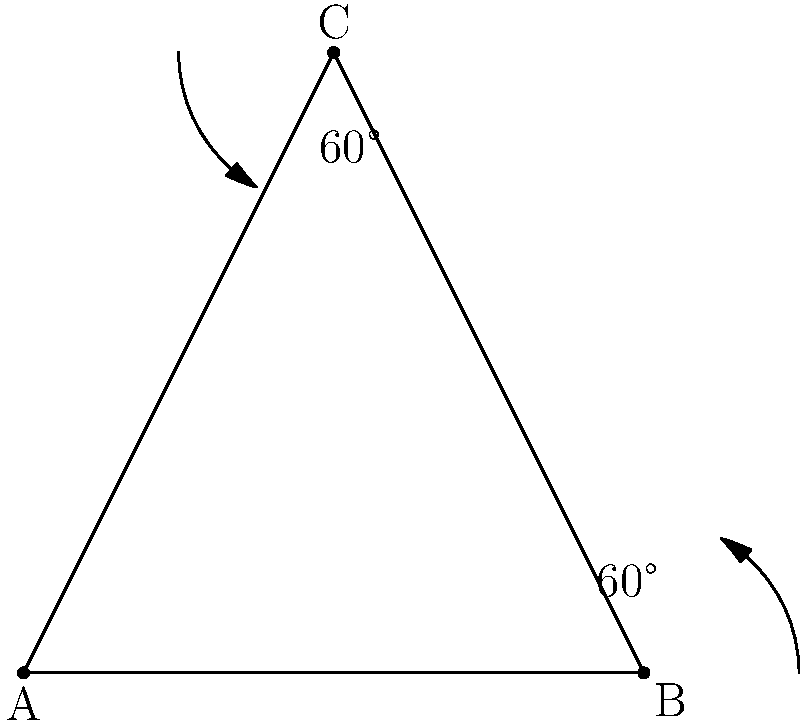In the spirit of understanding different prayer positions, consider a triangle formed by the hands and body during prayer. If the angle between the hands is 60°, and the angle between one hand and the body is also 60°, what is the measure of the third angle in this prayer triangle? Let's approach this step-by-step:

1) First, recall that the sum of angles in any triangle is always 180°. This is a fundamental property of triangles.

2) In our prayer triangle, we're given two angles:
   - The angle between the hands: 60°
   - The angle between one hand and the body: 60°

3) Let's call the third angle (the one we're looking for) $x$.

4) We can set up an equation based on the fact that all angles must sum to 180°:
   
   $60° + 60° + x = 180°$

5) Simplify the left side of the equation:
   
   $120° + x = 180°$

6) To solve for $x$, subtract 120° from both sides:
   
   $x = 180° - 120° = 60°$

Therefore, the measure of the third angle in this prayer triangle is also 60°.

This creates a special type of triangle known as an equilateral triangle, where all sides and angles are equal. In the context of prayer, this could symbolize balance and harmony in one's spiritual practice.
Answer: 60° 